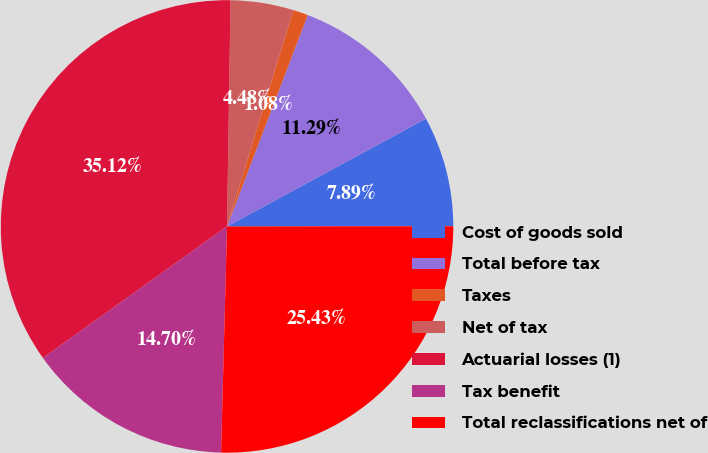Convert chart to OTSL. <chart><loc_0><loc_0><loc_500><loc_500><pie_chart><fcel>Cost of goods sold<fcel>Total before tax<fcel>Taxes<fcel>Net of tax<fcel>Actuarial losses (1)<fcel>Tax benefit<fcel>Total reclassifications net of<nl><fcel>7.89%<fcel>11.29%<fcel>1.08%<fcel>4.48%<fcel>35.12%<fcel>14.7%<fcel>25.43%<nl></chart> 